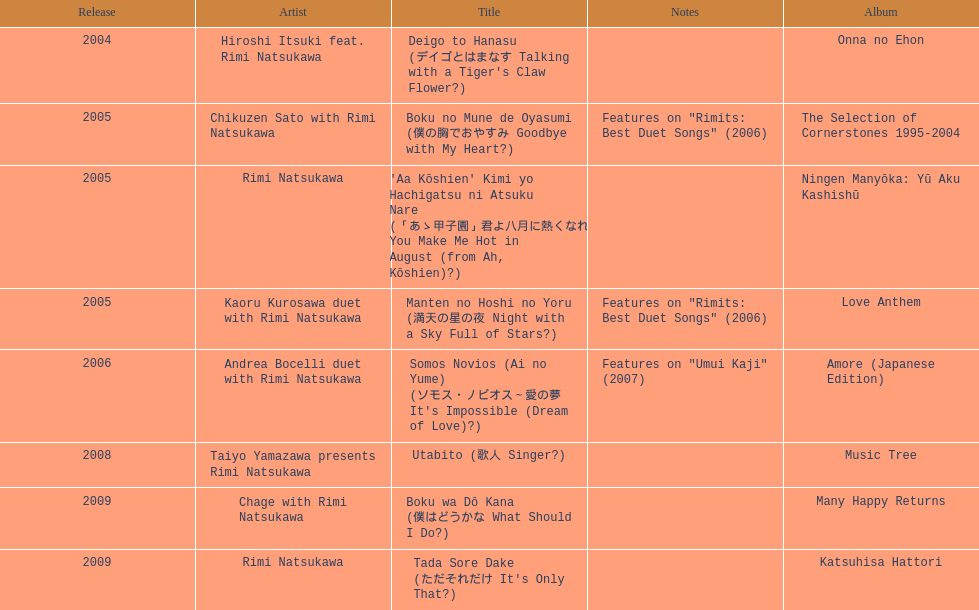How many titles have solely one artist? 2. 